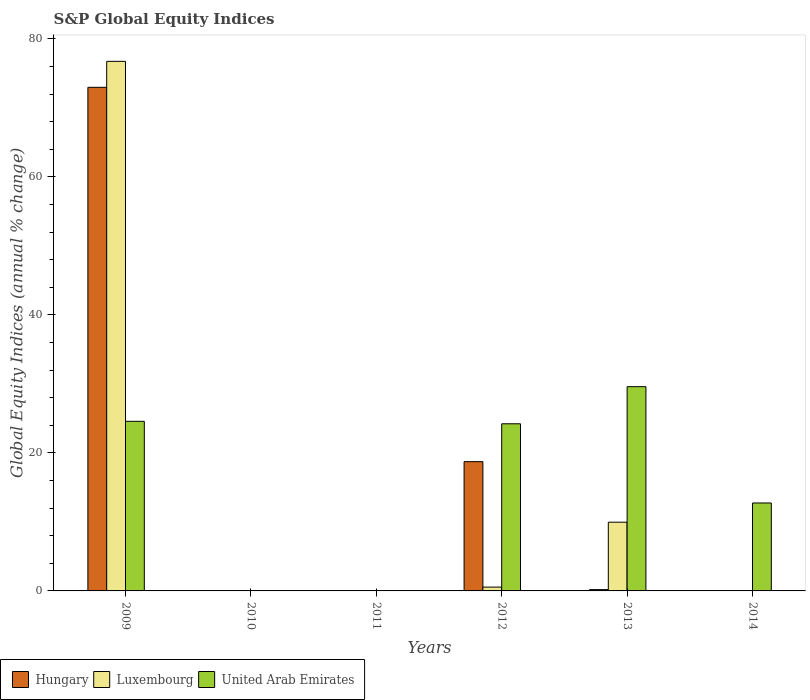Are the number of bars on each tick of the X-axis equal?
Keep it short and to the point. No. How many bars are there on the 2nd tick from the left?
Offer a very short reply. 0. What is the label of the 4th group of bars from the left?
Provide a short and direct response. 2012. What is the global equity indices in United Arab Emirates in 2011?
Make the answer very short. 0. Across all years, what is the maximum global equity indices in United Arab Emirates?
Your answer should be very brief. 29.59. In which year was the global equity indices in Hungary maximum?
Make the answer very short. 2009. What is the total global equity indices in Hungary in the graph?
Ensure brevity in your answer.  91.89. What is the difference between the global equity indices in United Arab Emirates in 2012 and that in 2013?
Provide a short and direct response. -5.38. What is the difference between the global equity indices in Hungary in 2011 and the global equity indices in Luxembourg in 2009?
Ensure brevity in your answer.  -76.73. What is the average global equity indices in United Arab Emirates per year?
Provide a succinct answer. 15.19. In the year 2013, what is the difference between the global equity indices in United Arab Emirates and global equity indices in Hungary?
Your answer should be very brief. 29.4. In how many years, is the global equity indices in Luxembourg greater than 56 %?
Your response must be concise. 1. What is the ratio of the global equity indices in United Arab Emirates in 2012 to that in 2014?
Provide a short and direct response. 1.9. Is the global equity indices in Luxembourg in 2012 less than that in 2013?
Your answer should be very brief. Yes. What is the difference between the highest and the second highest global equity indices in Hungary?
Your answer should be very brief. 54.24. What is the difference between the highest and the lowest global equity indices in Luxembourg?
Give a very brief answer. 76.73. In how many years, is the global equity indices in Hungary greater than the average global equity indices in Hungary taken over all years?
Your answer should be compact. 2. Is it the case that in every year, the sum of the global equity indices in United Arab Emirates and global equity indices in Hungary is greater than the global equity indices in Luxembourg?
Make the answer very short. No. How many bars are there?
Your answer should be compact. 10. Are the values on the major ticks of Y-axis written in scientific E-notation?
Give a very brief answer. No. How many legend labels are there?
Make the answer very short. 3. How are the legend labels stacked?
Provide a short and direct response. Horizontal. What is the title of the graph?
Provide a succinct answer. S&P Global Equity Indices. What is the label or title of the X-axis?
Your answer should be very brief. Years. What is the label or title of the Y-axis?
Your answer should be very brief. Global Equity Indices (annual % change). What is the Global Equity Indices (annual % change) in Hungary in 2009?
Your answer should be compact. 72.97. What is the Global Equity Indices (annual % change) of Luxembourg in 2009?
Keep it short and to the point. 76.73. What is the Global Equity Indices (annual % change) of United Arab Emirates in 2009?
Your response must be concise. 24.57. What is the Global Equity Indices (annual % change) in Hungary in 2010?
Offer a terse response. 0. What is the Global Equity Indices (annual % change) of Luxembourg in 2011?
Offer a very short reply. 0. What is the Global Equity Indices (annual % change) in Hungary in 2012?
Provide a short and direct response. 18.73. What is the Global Equity Indices (annual % change) of Luxembourg in 2012?
Keep it short and to the point. 0.55. What is the Global Equity Indices (annual % change) of United Arab Emirates in 2012?
Your answer should be very brief. 24.22. What is the Global Equity Indices (annual % change) in Hungary in 2013?
Make the answer very short. 0.19. What is the Global Equity Indices (annual % change) of Luxembourg in 2013?
Keep it short and to the point. 9.96. What is the Global Equity Indices (annual % change) in United Arab Emirates in 2013?
Your response must be concise. 29.59. What is the Global Equity Indices (annual % change) in United Arab Emirates in 2014?
Your answer should be compact. 12.74. Across all years, what is the maximum Global Equity Indices (annual % change) of Hungary?
Your answer should be very brief. 72.97. Across all years, what is the maximum Global Equity Indices (annual % change) in Luxembourg?
Give a very brief answer. 76.73. Across all years, what is the maximum Global Equity Indices (annual % change) of United Arab Emirates?
Offer a very short reply. 29.59. Across all years, what is the minimum Global Equity Indices (annual % change) of Luxembourg?
Keep it short and to the point. 0. Across all years, what is the minimum Global Equity Indices (annual % change) in United Arab Emirates?
Your answer should be compact. 0. What is the total Global Equity Indices (annual % change) in Hungary in the graph?
Your answer should be compact. 91.89. What is the total Global Equity Indices (annual % change) of Luxembourg in the graph?
Offer a very short reply. 87.24. What is the total Global Equity Indices (annual % change) of United Arab Emirates in the graph?
Make the answer very short. 91.13. What is the difference between the Global Equity Indices (annual % change) of Hungary in 2009 and that in 2012?
Make the answer very short. 54.24. What is the difference between the Global Equity Indices (annual % change) in Luxembourg in 2009 and that in 2012?
Your answer should be very brief. 76.18. What is the difference between the Global Equity Indices (annual % change) of United Arab Emirates in 2009 and that in 2012?
Your answer should be compact. 0.36. What is the difference between the Global Equity Indices (annual % change) of Hungary in 2009 and that in 2013?
Offer a very short reply. 72.78. What is the difference between the Global Equity Indices (annual % change) of Luxembourg in 2009 and that in 2013?
Your answer should be compact. 66.77. What is the difference between the Global Equity Indices (annual % change) in United Arab Emirates in 2009 and that in 2013?
Ensure brevity in your answer.  -5.02. What is the difference between the Global Equity Indices (annual % change) in United Arab Emirates in 2009 and that in 2014?
Provide a short and direct response. 11.83. What is the difference between the Global Equity Indices (annual % change) in Hungary in 2012 and that in 2013?
Ensure brevity in your answer.  18.54. What is the difference between the Global Equity Indices (annual % change) in Luxembourg in 2012 and that in 2013?
Give a very brief answer. -9.41. What is the difference between the Global Equity Indices (annual % change) in United Arab Emirates in 2012 and that in 2013?
Provide a short and direct response. -5.38. What is the difference between the Global Equity Indices (annual % change) of United Arab Emirates in 2012 and that in 2014?
Your answer should be compact. 11.47. What is the difference between the Global Equity Indices (annual % change) in United Arab Emirates in 2013 and that in 2014?
Your answer should be very brief. 16.85. What is the difference between the Global Equity Indices (annual % change) in Hungary in 2009 and the Global Equity Indices (annual % change) in Luxembourg in 2012?
Offer a terse response. 72.42. What is the difference between the Global Equity Indices (annual % change) of Hungary in 2009 and the Global Equity Indices (annual % change) of United Arab Emirates in 2012?
Your answer should be very brief. 48.75. What is the difference between the Global Equity Indices (annual % change) in Luxembourg in 2009 and the Global Equity Indices (annual % change) in United Arab Emirates in 2012?
Keep it short and to the point. 52.52. What is the difference between the Global Equity Indices (annual % change) in Hungary in 2009 and the Global Equity Indices (annual % change) in Luxembourg in 2013?
Provide a succinct answer. 63.01. What is the difference between the Global Equity Indices (annual % change) in Hungary in 2009 and the Global Equity Indices (annual % change) in United Arab Emirates in 2013?
Your answer should be compact. 43.38. What is the difference between the Global Equity Indices (annual % change) in Luxembourg in 2009 and the Global Equity Indices (annual % change) in United Arab Emirates in 2013?
Your answer should be very brief. 47.14. What is the difference between the Global Equity Indices (annual % change) in Hungary in 2009 and the Global Equity Indices (annual % change) in United Arab Emirates in 2014?
Make the answer very short. 60.23. What is the difference between the Global Equity Indices (annual % change) in Luxembourg in 2009 and the Global Equity Indices (annual % change) in United Arab Emirates in 2014?
Make the answer very short. 63.99. What is the difference between the Global Equity Indices (annual % change) of Hungary in 2012 and the Global Equity Indices (annual % change) of Luxembourg in 2013?
Make the answer very short. 8.77. What is the difference between the Global Equity Indices (annual % change) in Hungary in 2012 and the Global Equity Indices (annual % change) in United Arab Emirates in 2013?
Give a very brief answer. -10.86. What is the difference between the Global Equity Indices (annual % change) in Luxembourg in 2012 and the Global Equity Indices (annual % change) in United Arab Emirates in 2013?
Keep it short and to the point. -29.04. What is the difference between the Global Equity Indices (annual % change) of Hungary in 2012 and the Global Equity Indices (annual % change) of United Arab Emirates in 2014?
Keep it short and to the point. 5.99. What is the difference between the Global Equity Indices (annual % change) of Luxembourg in 2012 and the Global Equity Indices (annual % change) of United Arab Emirates in 2014?
Ensure brevity in your answer.  -12.19. What is the difference between the Global Equity Indices (annual % change) in Hungary in 2013 and the Global Equity Indices (annual % change) in United Arab Emirates in 2014?
Your answer should be very brief. -12.55. What is the difference between the Global Equity Indices (annual % change) of Luxembourg in 2013 and the Global Equity Indices (annual % change) of United Arab Emirates in 2014?
Ensure brevity in your answer.  -2.78. What is the average Global Equity Indices (annual % change) in Hungary per year?
Make the answer very short. 15.31. What is the average Global Equity Indices (annual % change) in Luxembourg per year?
Ensure brevity in your answer.  14.54. What is the average Global Equity Indices (annual % change) in United Arab Emirates per year?
Offer a very short reply. 15.19. In the year 2009, what is the difference between the Global Equity Indices (annual % change) of Hungary and Global Equity Indices (annual % change) of Luxembourg?
Provide a succinct answer. -3.76. In the year 2009, what is the difference between the Global Equity Indices (annual % change) in Hungary and Global Equity Indices (annual % change) in United Arab Emirates?
Make the answer very short. 48.39. In the year 2009, what is the difference between the Global Equity Indices (annual % change) in Luxembourg and Global Equity Indices (annual % change) in United Arab Emirates?
Keep it short and to the point. 52.16. In the year 2012, what is the difference between the Global Equity Indices (annual % change) of Hungary and Global Equity Indices (annual % change) of Luxembourg?
Your answer should be very brief. 18.18. In the year 2012, what is the difference between the Global Equity Indices (annual % change) of Hungary and Global Equity Indices (annual % change) of United Arab Emirates?
Ensure brevity in your answer.  -5.49. In the year 2012, what is the difference between the Global Equity Indices (annual % change) in Luxembourg and Global Equity Indices (annual % change) in United Arab Emirates?
Offer a terse response. -23.66. In the year 2013, what is the difference between the Global Equity Indices (annual % change) of Hungary and Global Equity Indices (annual % change) of Luxembourg?
Your response must be concise. -9.77. In the year 2013, what is the difference between the Global Equity Indices (annual % change) of Hungary and Global Equity Indices (annual % change) of United Arab Emirates?
Provide a short and direct response. -29.4. In the year 2013, what is the difference between the Global Equity Indices (annual % change) in Luxembourg and Global Equity Indices (annual % change) in United Arab Emirates?
Offer a terse response. -19.63. What is the ratio of the Global Equity Indices (annual % change) of Hungary in 2009 to that in 2012?
Give a very brief answer. 3.9. What is the ratio of the Global Equity Indices (annual % change) in Luxembourg in 2009 to that in 2012?
Give a very brief answer. 138.88. What is the ratio of the Global Equity Indices (annual % change) of United Arab Emirates in 2009 to that in 2012?
Provide a short and direct response. 1.01. What is the ratio of the Global Equity Indices (annual % change) of Hungary in 2009 to that in 2013?
Your answer should be very brief. 387.64. What is the ratio of the Global Equity Indices (annual % change) in Luxembourg in 2009 to that in 2013?
Give a very brief answer. 7.71. What is the ratio of the Global Equity Indices (annual % change) in United Arab Emirates in 2009 to that in 2013?
Make the answer very short. 0.83. What is the ratio of the Global Equity Indices (annual % change) of United Arab Emirates in 2009 to that in 2014?
Keep it short and to the point. 1.93. What is the ratio of the Global Equity Indices (annual % change) in Hungary in 2012 to that in 2013?
Offer a very short reply. 99.51. What is the ratio of the Global Equity Indices (annual % change) in Luxembourg in 2012 to that in 2013?
Offer a terse response. 0.06. What is the ratio of the Global Equity Indices (annual % change) in United Arab Emirates in 2012 to that in 2013?
Keep it short and to the point. 0.82. What is the ratio of the Global Equity Indices (annual % change) in United Arab Emirates in 2012 to that in 2014?
Offer a terse response. 1.9. What is the ratio of the Global Equity Indices (annual % change) of United Arab Emirates in 2013 to that in 2014?
Keep it short and to the point. 2.32. What is the difference between the highest and the second highest Global Equity Indices (annual % change) of Hungary?
Provide a short and direct response. 54.24. What is the difference between the highest and the second highest Global Equity Indices (annual % change) of Luxembourg?
Keep it short and to the point. 66.77. What is the difference between the highest and the second highest Global Equity Indices (annual % change) of United Arab Emirates?
Your answer should be compact. 5.02. What is the difference between the highest and the lowest Global Equity Indices (annual % change) in Hungary?
Keep it short and to the point. 72.97. What is the difference between the highest and the lowest Global Equity Indices (annual % change) of Luxembourg?
Your answer should be compact. 76.73. What is the difference between the highest and the lowest Global Equity Indices (annual % change) in United Arab Emirates?
Offer a very short reply. 29.59. 